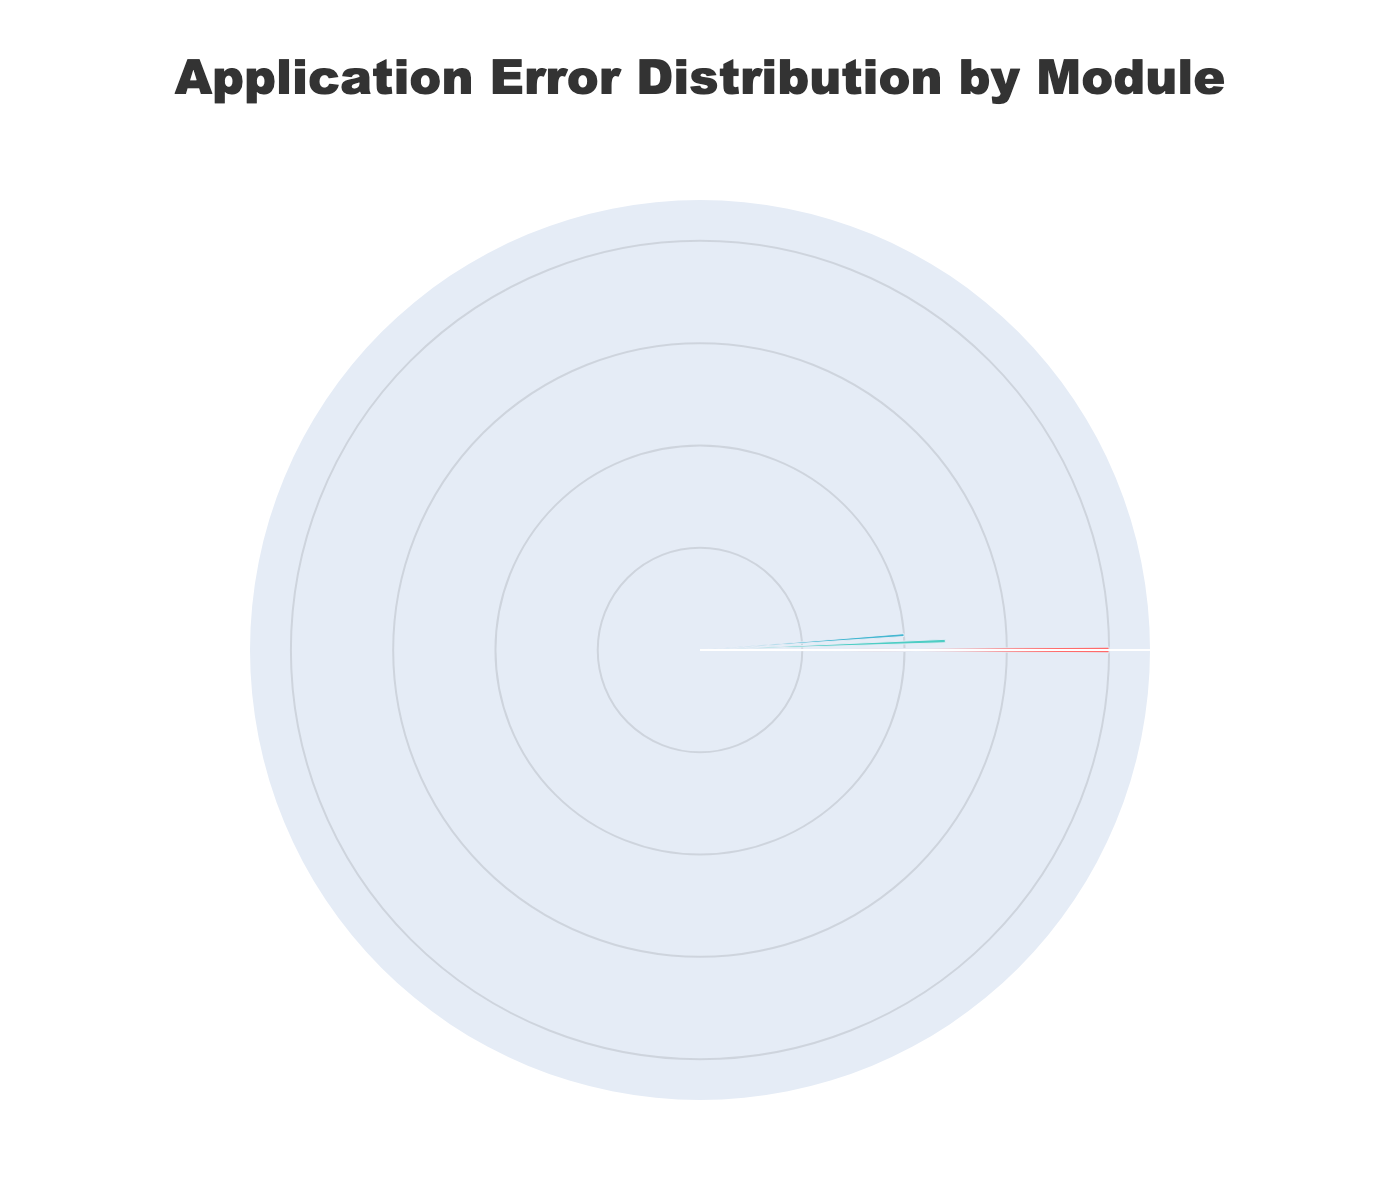what is the title of the figure? The title is the main text that appears at the top of the figure, usually providing a description of what the chart represents. In this case, the title is displayed as "Application Error Distribution by Module".
Answer: Application Error Distribution by Module How many modules are represented in the rose chart? By analyzing the figure, we can identify the distinct segments around the polar axis that correspond to different modules. In this rose chart, there are three distinct modules.
Answer: 3 Which module has the highest error count? To determine which module has the highest error count, we look at the length of the bars in the rose chart. The module with the longest bar represents the highest error count. In this case, the Authentication module has the highest error count with 200 errors.
Answer: Authentication What is the total error count for the Payment module? To find the total error count for the Payment module, we sum the error counts for each error type under this module. From the bar lengths, we find that the total is the sum of 50 (Timeout) and 70 (ProcessingError).
Answer: 120 Which two modules have an equal total error count? By examining the length of the bars corresponding to each module, we can see that both the Authentication and Payment modules have bars of equal length. They both have a total error count of 200 and 120 respectively.
Answer: None What is the difference in error count between the Authentication and UserProfile modules? To find the difference in error count between the Authentication and UserProfile modules, we subtract the total error count of UserProfile (100) from that of Authentication (200).
Answer: 100 Is the error count of UserProfile greater than the sum of Timeout errors across all modules? First, find the total Timeout errors across all modules, which is 120 (Authentication) + 50 (Payment) = 170. Then compare it with the total error count of UserProfile, which is 100. Since 100 is less than 170, the UserProfile error count is not greater.
Answer: No Which has more errors: DataRetrievalError in UserProfile or ProcessingError in Payment? By comparing the individual bars for these error types, it is evident that DataRetrievalError in UserProfile has an error count of 60, whereas ProcessingError in Payment has an error count of 70. Hence, ProcessingError has more errors.
Answer: ProcessingError in Payment What is the collective error count for all modules combined? To obtain the total error count for all modules, sum the values of error counts for each module: 120 (Timeout) + 80 (InvalidCredentials) for Authentication, 50 (Timeout) + 70 (ProcessingError) for Payment, and 60 (DataRetrievalError) + 40 (InvalidDataFormat) for UserProfile. Total is 360.
Answer: 360 